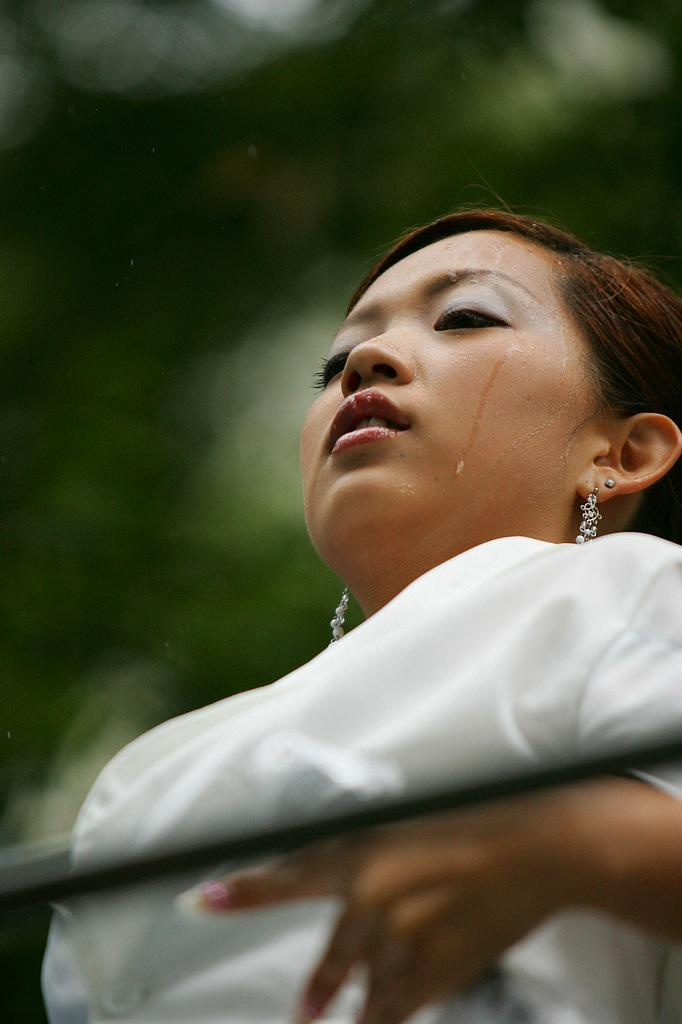Who is the main subject in the image? There is a woman in the image. What is the woman wearing? The woman is wearing a white dress. Can you describe the background of the image? The background of the image is blurred. What type of ice can be seen on the top of the woman's head in the image? There is no ice present on the woman's head or anywhere else in the image. 